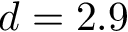<formula> <loc_0><loc_0><loc_500><loc_500>d = 2 . 9</formula> 